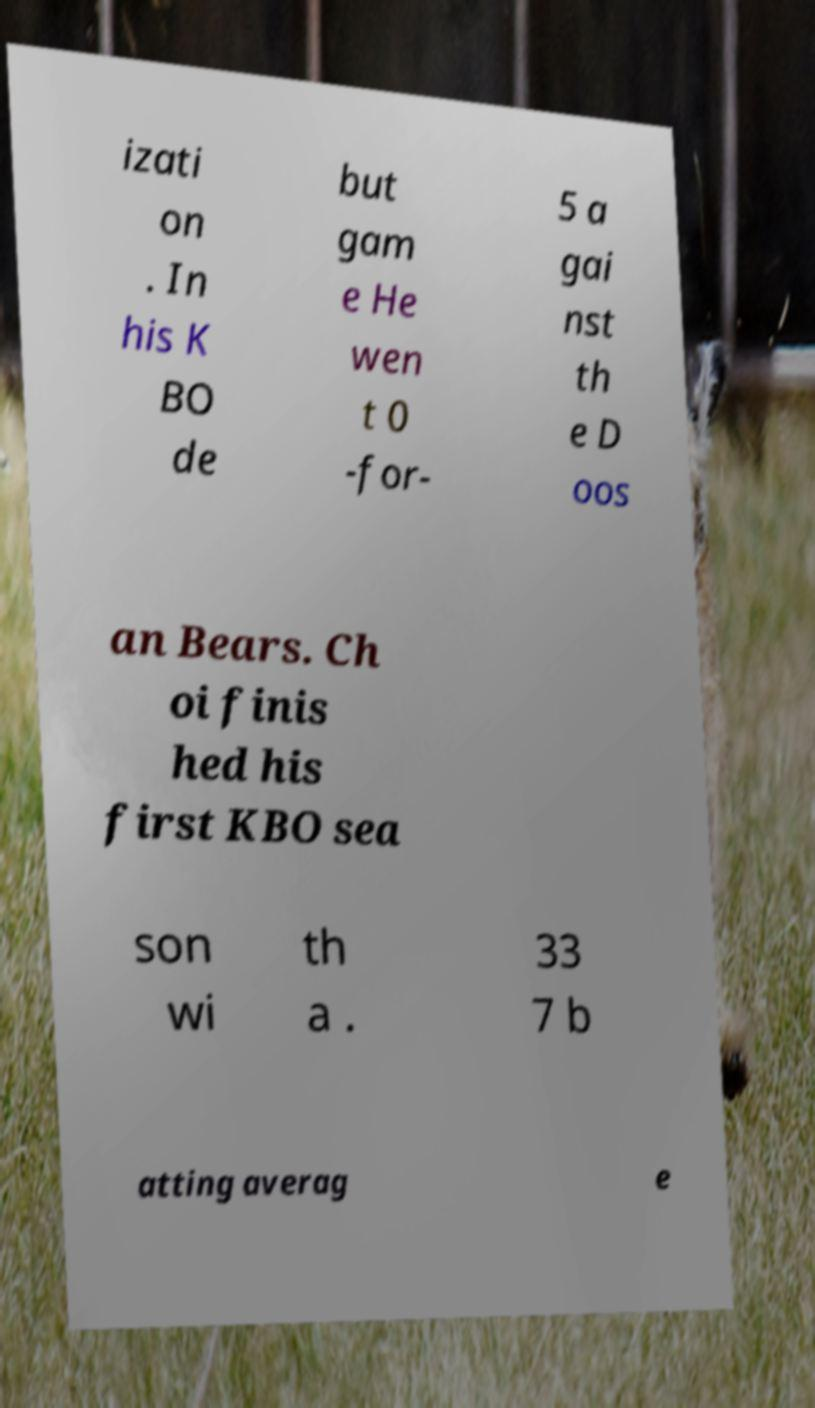There's text embedded in this image that I need extracted. Can you transcribe it verbatim? izati on . In his K BO de but gam e He wen t 0 -for- 5 a gai nst th e D oos an Bears. Ch oi finis hed his first KBO sea son wi th a . 33 7 b atting averag e 